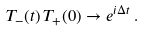<formula> <loc_0><loc_0><loc_500><loc_500>T _ { - } ( t ) \, T _ { + } ( 0 ) \to e ^ { i \Delta t } \, .</formula> 